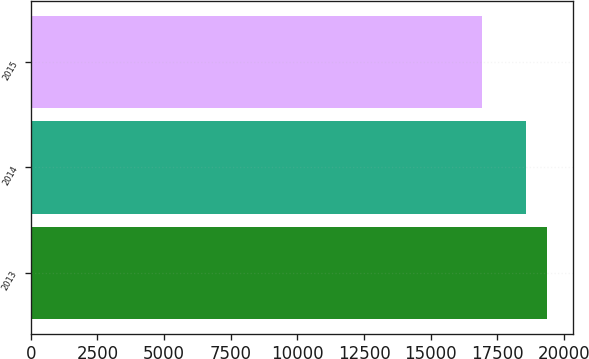Convert chart. <chart><loc_0><loc_0><loc_500><loc_500><bar_chart><fcel>2013<fcel>2014<fcel>2015<nl><fcel>19381<fcel>18564<fcel>16939<nl></chart> 